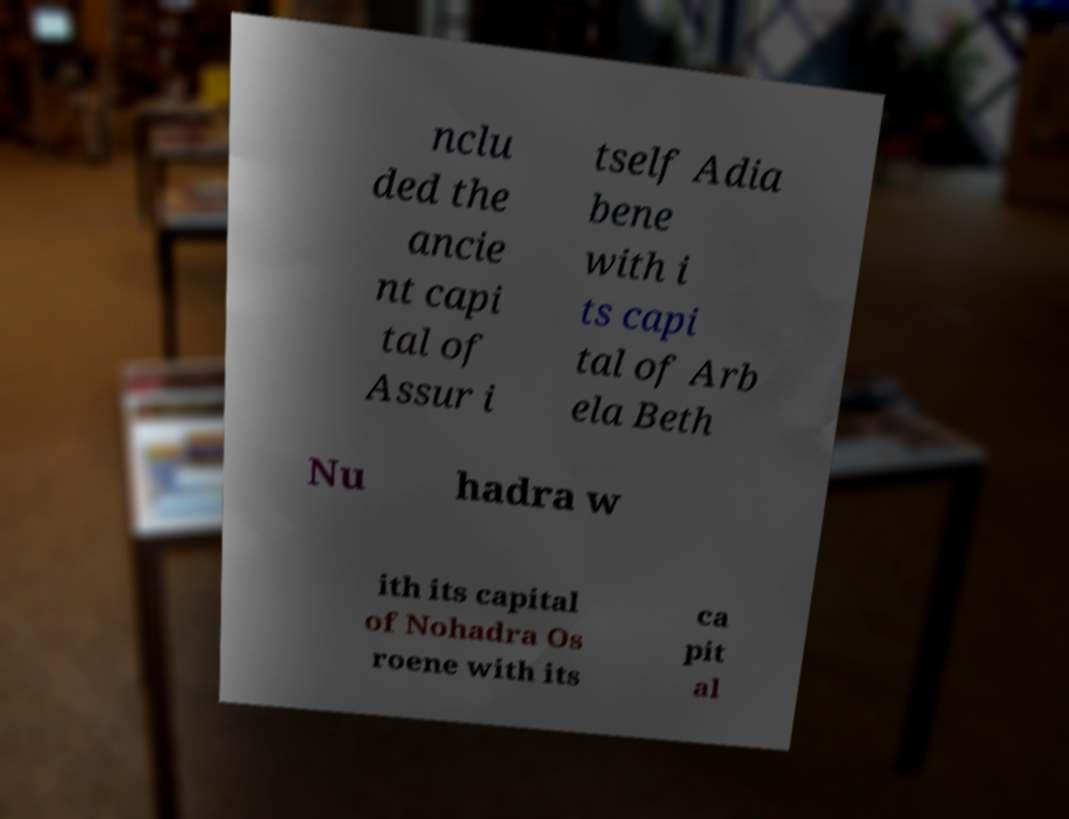What messages or text are displayed in this image? I need them in a readable, typed format. nclu ded the ancie nt capi tal of Assur i tself Adia bene with i ts capi tal of Arb ela Beth Nu hadra w ith its capital of Nohadra Os roene with its ca pit al 